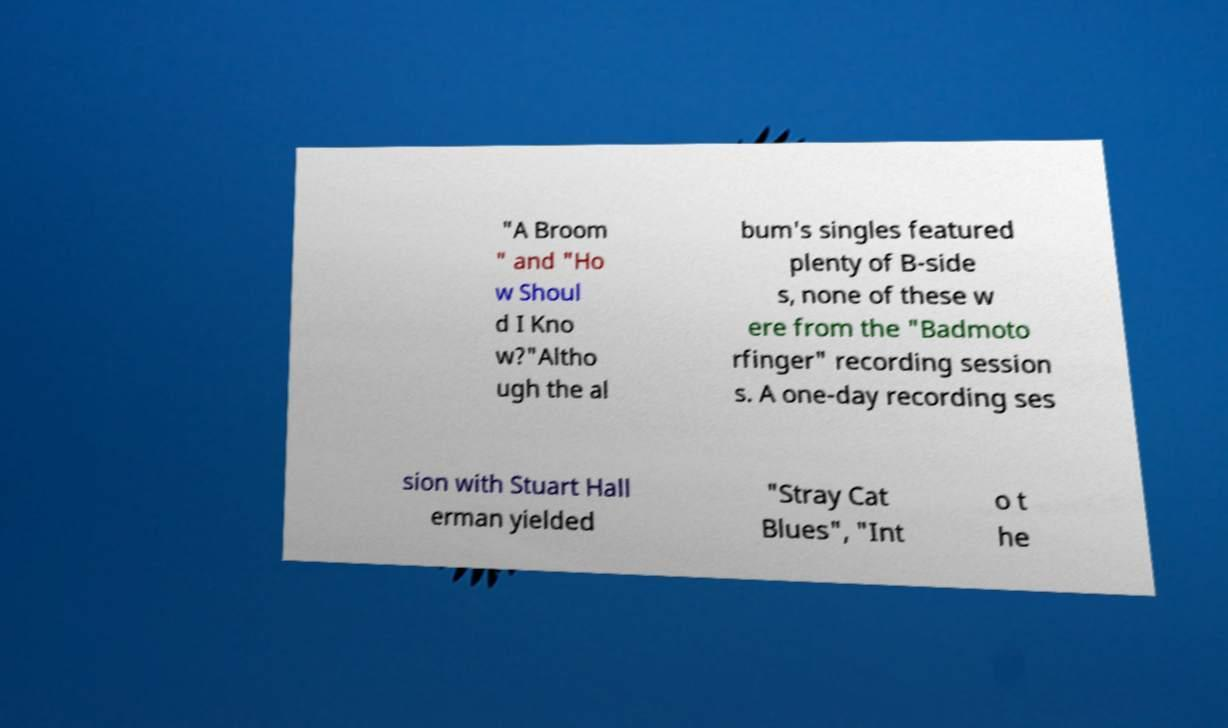Could you assist in decoding the text presented in this image and type it out clearly? "A Broom " and "Ho w Shoul d I Kno w?"Altho ugh the al bum's singles featured plenty of B-side s, none of these w ere from the "Badmoto rfinger" recording session s. A one-day recording ses sion with Stuart Hall erman yielded "Stray Cat Blues", "Int o t he 